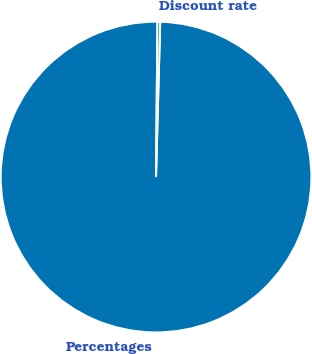Convert chart. <chart><loc_0><loc_0><loc_500><loc_500><pie_chart><fcel>Percentages<fcel>Discount rate<nl><fcel>99.71%<fcel>0.29%<nl></chart> 